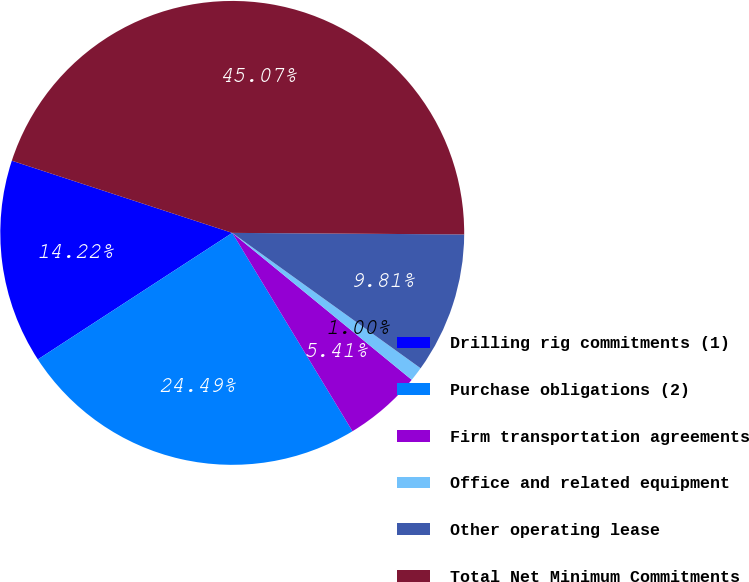Convert chart to OTSL. <chart><loc_0><loc_0><loc_500><loc_500><pie_chart><fcel>Drilling rig commitments (1)<fcel>Purchase obligations (2)<fcel>Firm transportation agreements<fcel>Office and related equipment<fcel>Other operating lease<fcel>Total Net Minimum Commitments<nl><fcel>14.22%<fcel>24.49%<fcel>5.41%<fcel>1.0%<fcel>9.81%<fcel>45.07%<nl></chart> 